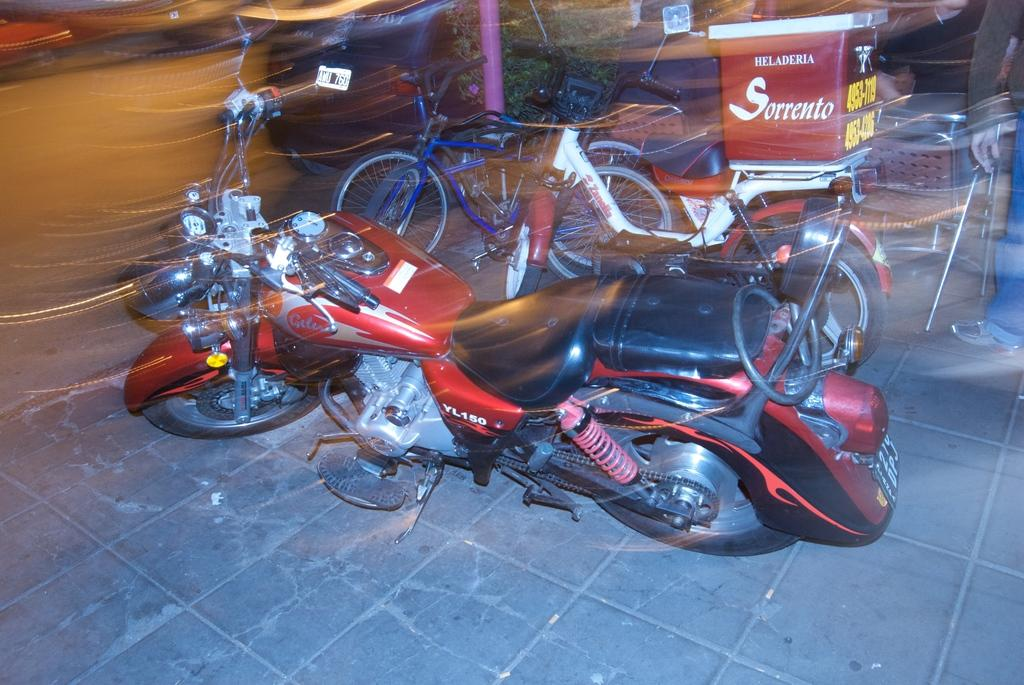What type of vehicles are parked on the road in the image? There are bikes and bicycles in the image. Where are the bikes and bicycles located? The bikes and bicycles are parked on the road. What can be seen behind the parked bikes and bicycles? There are people standing behind them. What are some people doing in the background of the image? Some people are sitting on chairs in the background. What type of powder is being used to clean the bikes and bicycles in the image? There is no powder visible in the image, and no cleaning activity is taking place. 